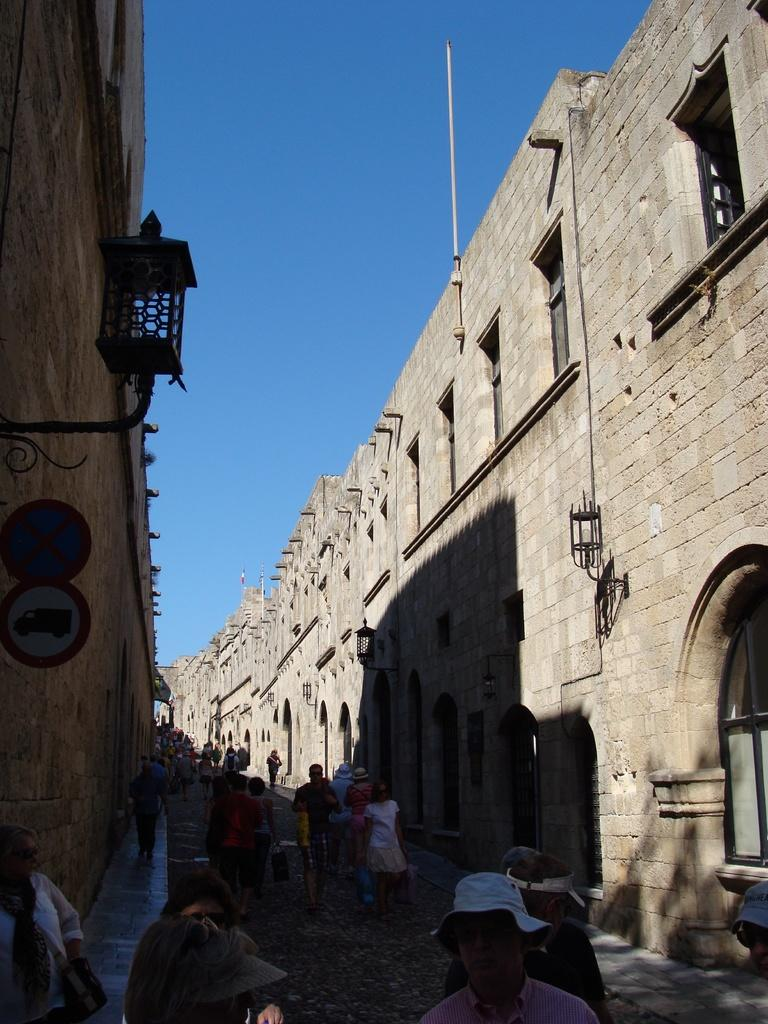What type of structures can be seen in the image? There are buildings in the image. What feature of the buildings is visible? There are windows visible in the image. What can be seen illuminating the scene? There are lights in the image. What are the vertical structures in the image used for? There are poles in the image, which are likely used for supporting wires or signs. What type of information might be conveyed by the vertical structures? There are signboards in the image, which may display information or advertisements. What is happening on the ground in the image? There are people walking on the road in the image. What is the color of the sky in the image? The sky is blue in the image. What type of skin is visible on the people in the image? There is no mention of people's skin in the image. --- Facts: 1. There is a car in the image. 12. The car is red. 13. There are people standing near the car. 14. The car has four wheels. 15. The car has a license plate. Absurd Topics: unicorn, rainbow, umbrella Conversation: What type of vehicle is in the image? There is a car in the image. What is the color of the car? The car is red. What are the people doing near the car? There are people standing near the car. How many wheels does the car have? The car has four wheels. Does the car have any identifying features? The car has a license plate. Reasoning: Let's think step by step in order to produce the conversation. We start by identifying the main subject of the image, which is the car. Next, we describe specific features of the car, such as the color and the number of wheels. Then, we observe the actions of the people in the image, noting that they are standing near the car. Finally, we describe any other identifying features of the car, such as the license plate. Absurd Question/Answer: Can you see a unicorn in the image? There is no unicorn present in the image. --- Facts: 1. There is a dog in the image. 12. The dog is brown. 13. The dog is wagging its tail. 14. There is a leash attached to the dog. 15. The dog is sitting on the grass. Absurd Topics: flying squirrel, leprechaun, lollipop Conversation: What type of animal is in the image? There is a dog in the image. What is the color of the dog? The dog is brown. What is the dog doing in the image? The dog is wagging its tail. 